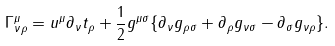<formula> <loc_0><loc_0><loc_500><loc_500>\Gamma _ { \nu \rho } ^ { \mu } = u ^ { \mu } \partial _ { \nu } t _ { \rho } + \frac { 1 } { 2 } g ^ { \mu \sigma } \{ \partial _ { \nu } g _ { \rho \sigma } + \partial _ { \rho } g _ { \nu \sigma } - \partial _ { \sigma } g _ { \nu \rho } \} .</formula> 